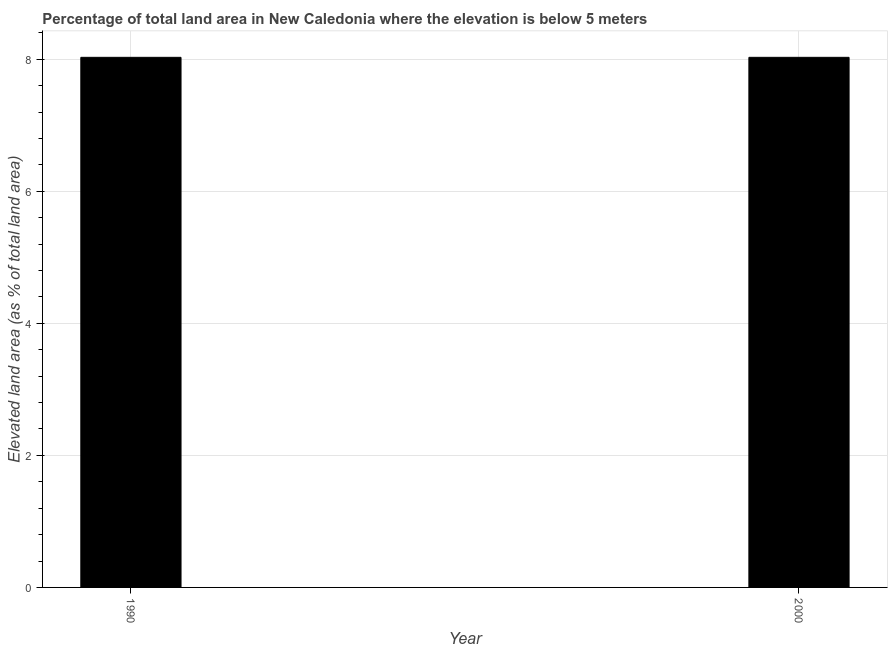What is the title of the graph?
Give a very brief answer. Percentage of total land area in New Caledonia where the elevation is below 5 meters. What is the label or title of the Y-axis?
Your answer should be very brief. Elevated land area (as % of total land area). What is the total elevated land area in 1990?
Your answer should be very brief. 8.03. Across all years, what is the maximum total elevated land area?
Offer a terse response. 8.03. Across all years, what is the minimum total elevated land area?
Keep it short and to the point. 8.03. What is the sum of the total elevated land area?
Keep it short and to the point. 16.06. What is the average total elevated land area per year?
Keep it short and to the point. 8.03. What is the median total elevated land area?
Your answer should be very brief. 8.03. In how many years, is the total elevated land area greater than 8 %?
Give a very brief answer. 2. In how many years, is the total elevated land area greater than the average total elevated land area taken over all years?
Your answer should be compact. 0. How many bars are there?
Make the answer very short. 2. What is the difference between two consecutive major ticks on the Y-axis?
Provide a short and direct response. 2. What is the Elevated land area (as % of total land area) in 1990?
Keep it short and to the point. 8.03. What is the Elevated land area (as % of total land area) of 2000?
Your response must be concise. 8.03. What is the difference between the Elevated land area (as % of total land area) in 1990 and 2000?
Your answer should be very brief. 0. 